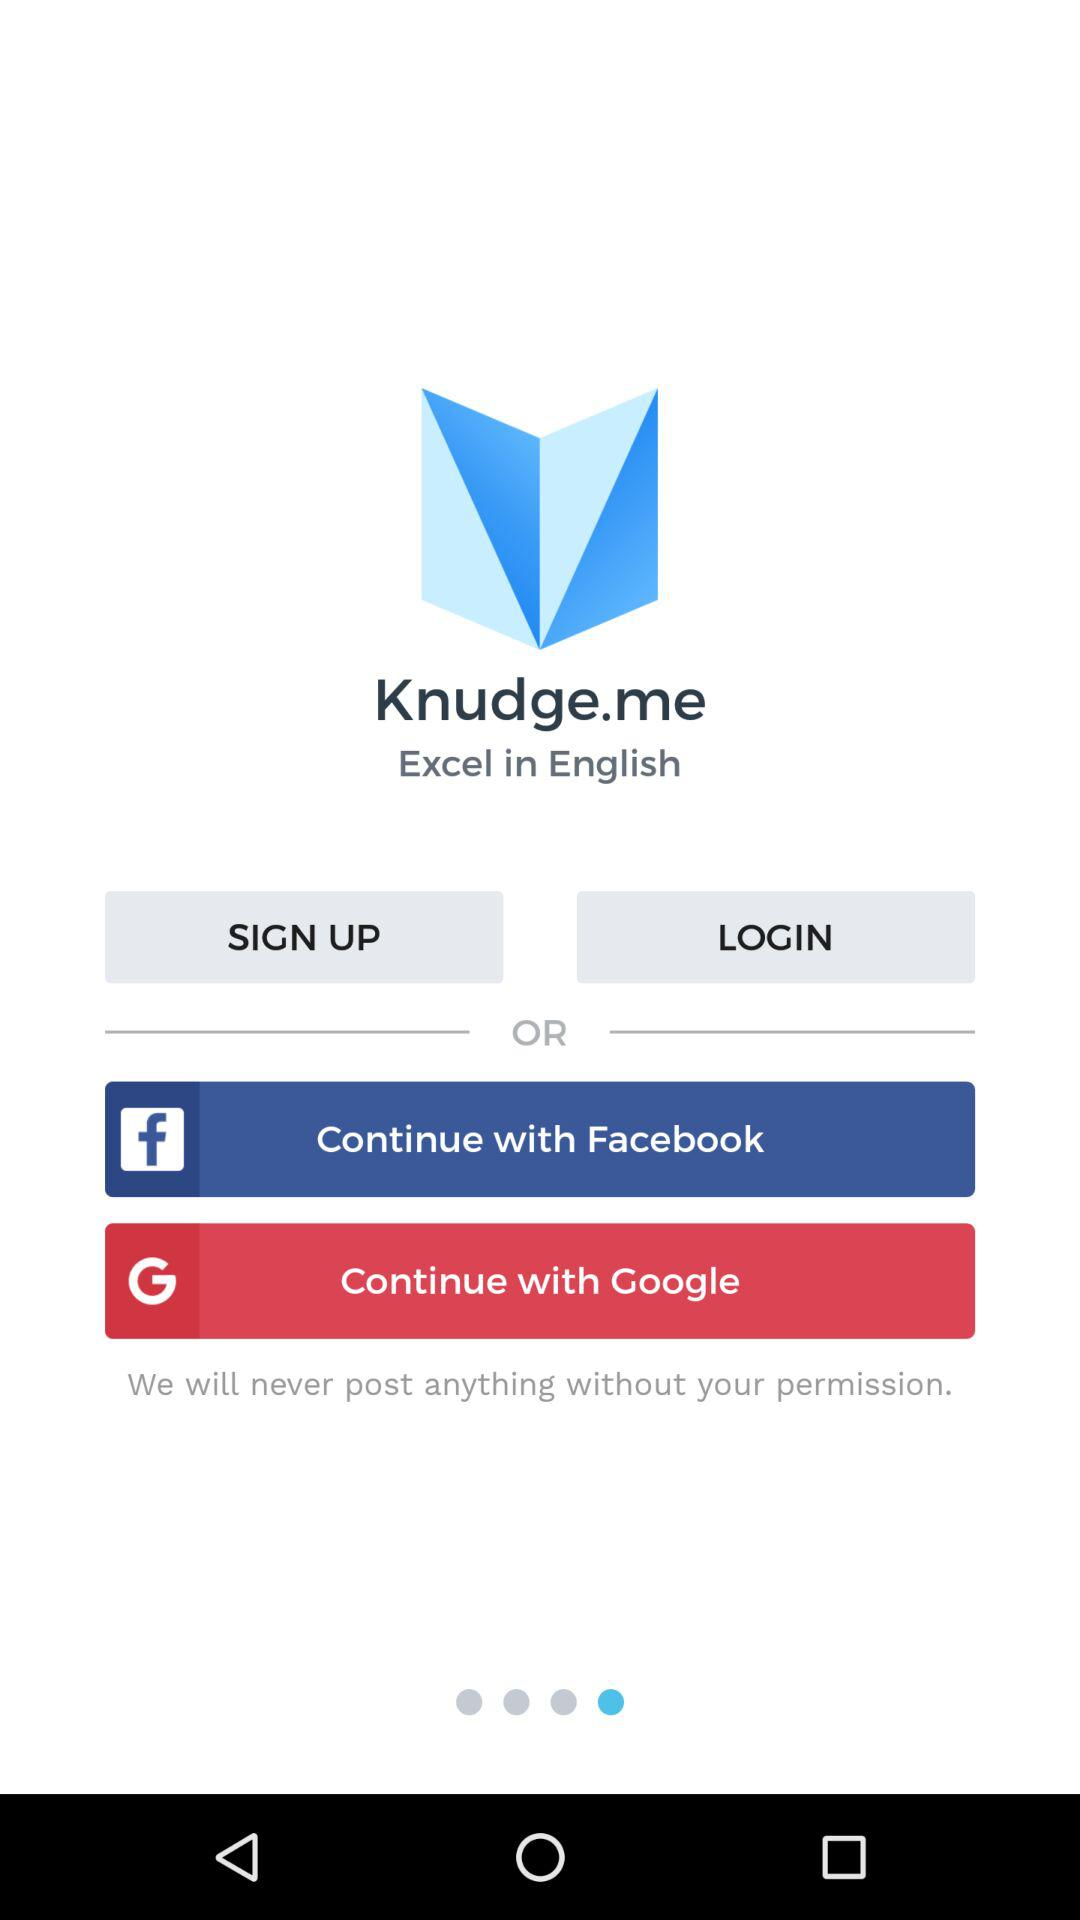What is the name of the application? The name of the application is "Knudge.me". 